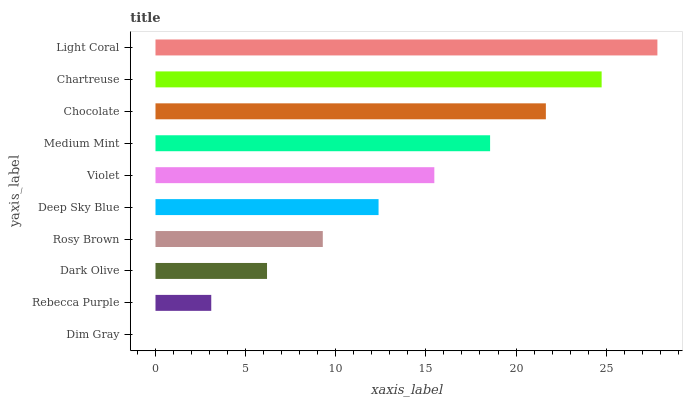Is Dim Gray the minimum?
Answer yes or no. Yes. Is Light Coral the maximum?
Answer yes or no. Yes. Is Rebecca Purple the minimum?
Answer yes or no. No. Is Rebecca Purple the maximum?
Answer yes or no. No. Is Rebecca Purple greater than Dim Gray?
Answer yes or no. Yes. Is Dim Gray less than Rebecca Purple?
Answer yes or no. Yes. Is Dim Gray greater than Rebecca Purple?
Answer yes or no. No. Is Rebecca Purple less than Dim Gray?
Answer yes or no. No. Is Violet the high median?
Answer yes or no. Yes. Is Deep Sky Blue the low median?
Answer yes or no. Yes. Is Light Coral the high median?
Answer yes or no. No. Is Rosy Brown the low median?
Answer yes or no. No. 